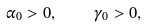<formula> <loc_0><loc_0><loc_500><loc_500>\alpha _ { 0 } > 0 , \quad \gamma _ { 0 } > 0 ,</formula> 